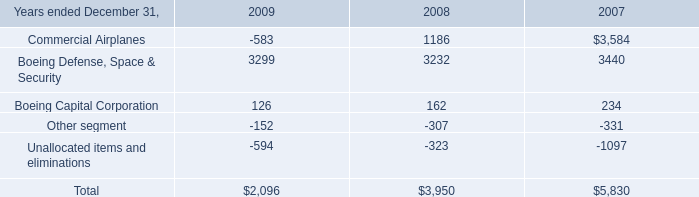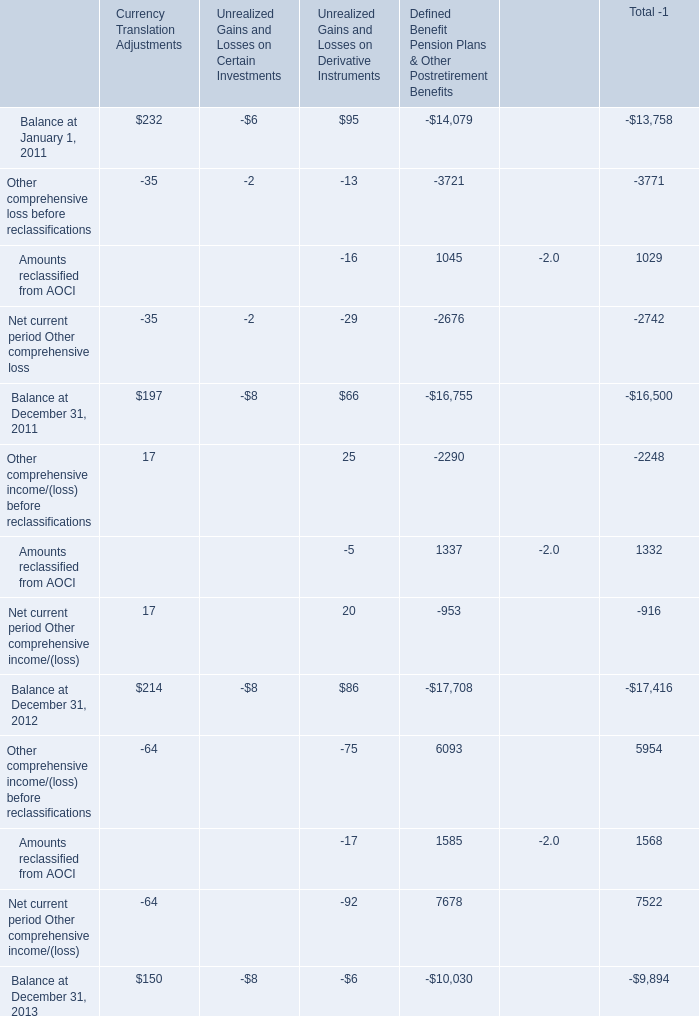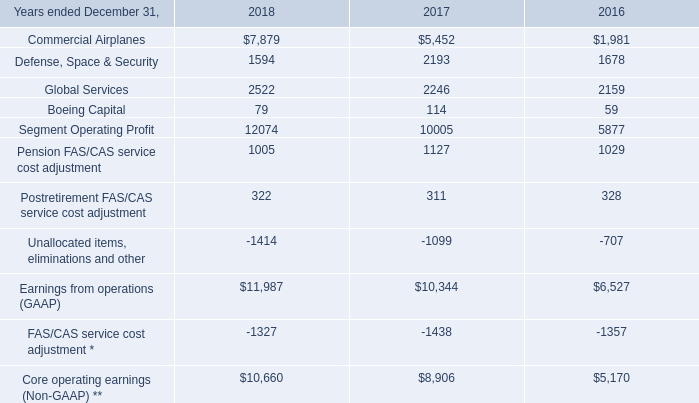What's the average of Currency Translation Adjustments and Unrealized Gains and Losses on Derivative Instruments in 2011? 
Computations: ((197 + 66) / 2)
Answer: 131.5. 